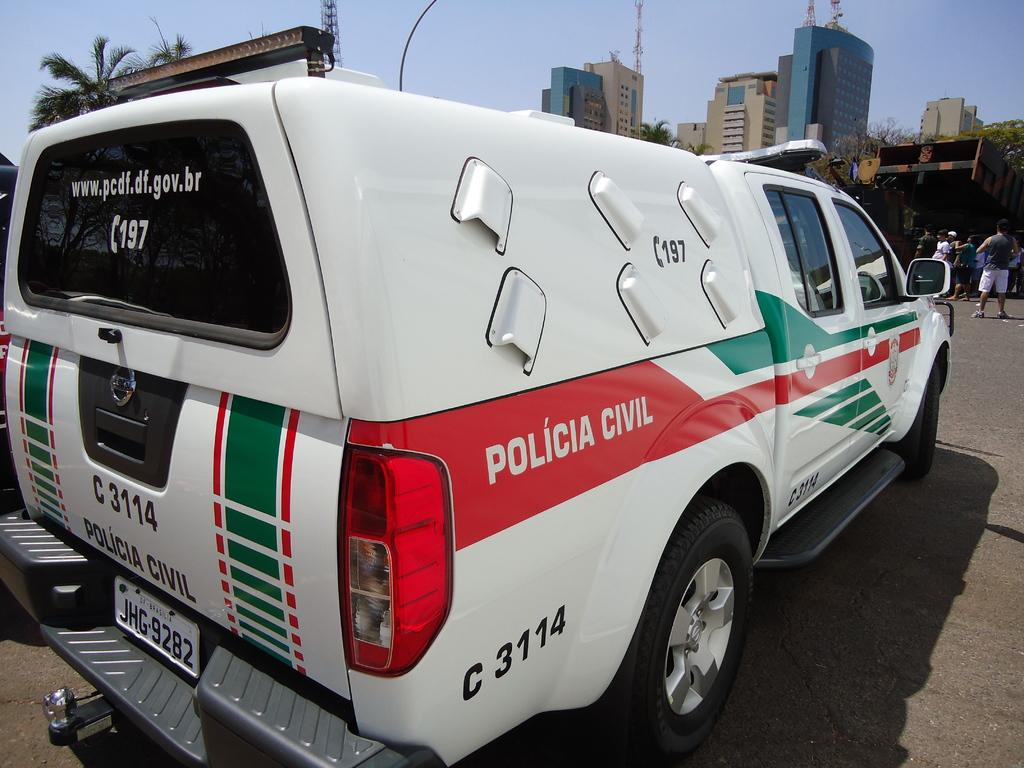<image>
Share a concise interpretation of the image provided. white Policia Civil truck in a parking lot 